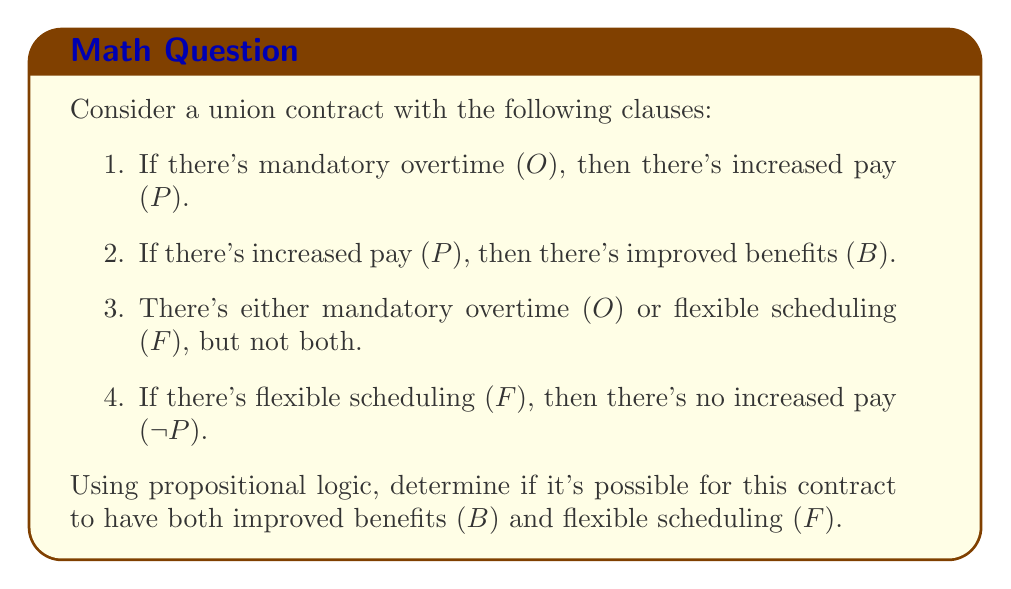Solve this math problem. Let's approach this step-by-step using propositional logic:

1. First, let's translate the given clauses into logical statements:
   a. $O \rightarrow P$
   b. $P \rightarrow B$
   c. $(O \lor F) \land \neg(O \land F)$, which is equivalent to $O \oplus F$ (exclusive OR)
   d. $F \rightarrow \neg P$

2. We want to determine if it's possible to have both B and F. Let's assume this is true and see if it leads to a contradiction:
   $B \land F$

3. If F is true, then by clause 4: $F \rightarrow \neg P$, we know that P must be false.

4. However, if B is true, then by clause 2: $P \rightarrow B$, we know that P must be true (because if P were false, B could be either true or false, but we're assuming B is true).

5. This creates a contradiction: P must be both true and false.

6. We can also approach this from another angle:
   If F is true, then by clause 3, O must be false.
   If O is false, then by clause 1, we can't conclude anything about P.
   If P is false (which it must be if F is true), then by clause 2, we can't conclude anything about B.

7. This means that when F is true, we can't guarantee that B is true.

Therefore, it's not possible for this contract to have both improved benefits (B) and flexible scheduling (F) simultaneously.
Answer: No, it's not possible for the contract to have both improved benefits (B) and flexible scheduling (F) simultaneously. 